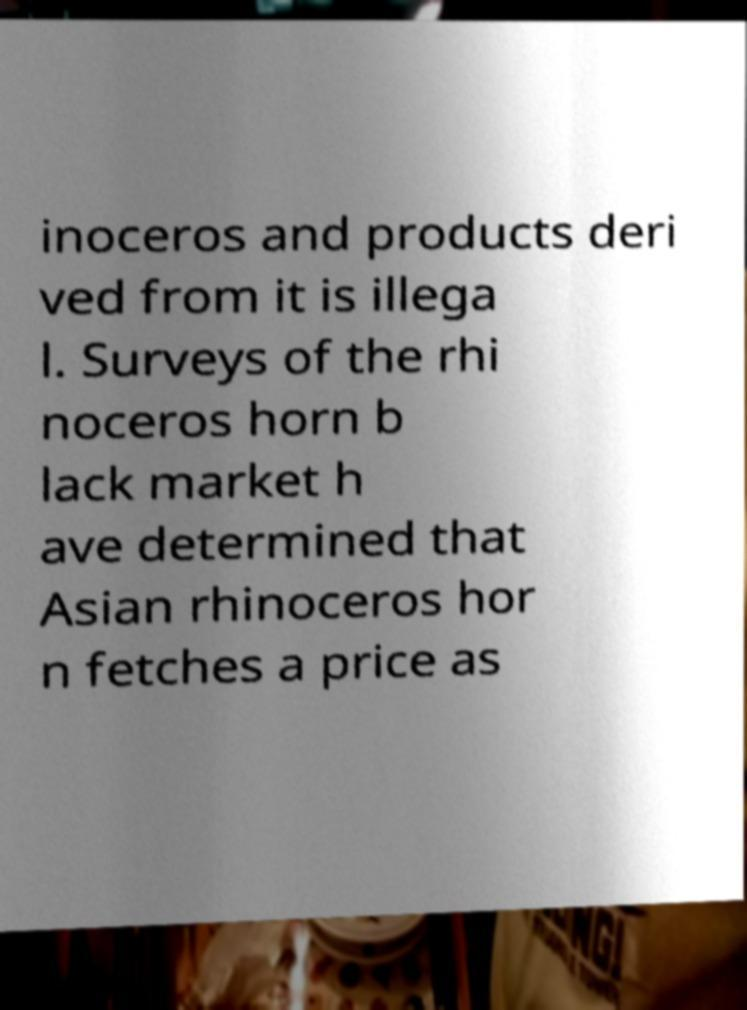Could you assist in decoding the text presented in this image and type it out clearly? inoceros and products deri ved from it is illega l. Surveys of the rhi noceros horn b lack market h ave determined that Asian rhinoceros hor n fetches a price as 